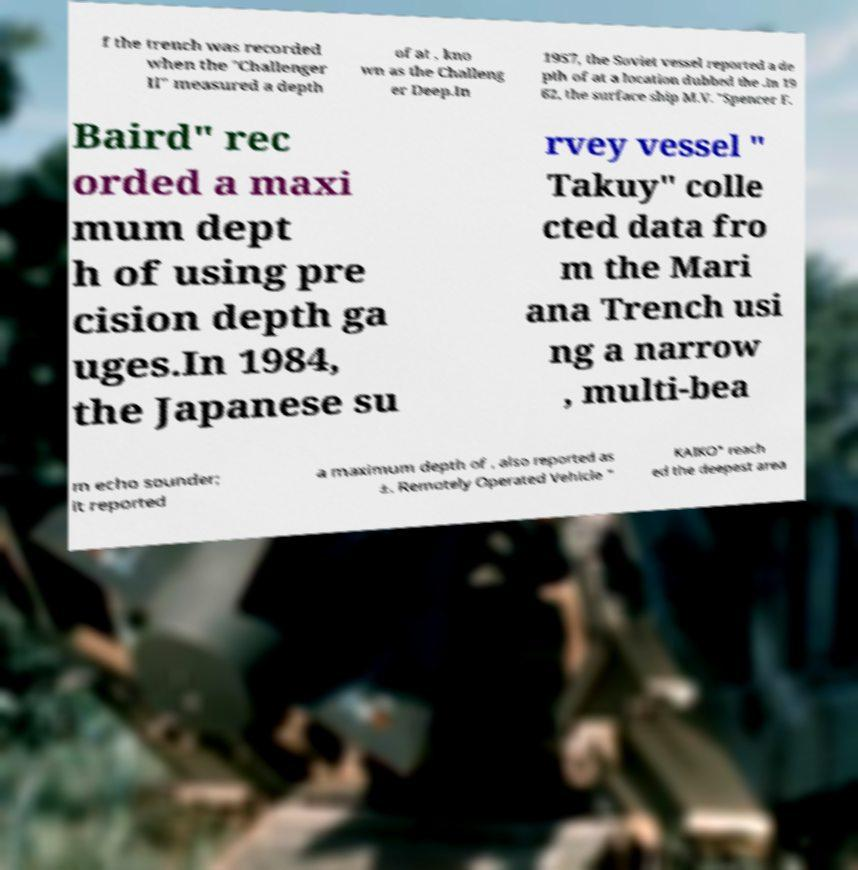Can you read and provide the text displayed in the image?This photo seems to have some interesting text. Can you extract and type it out for me? f the trench was recorded when the "Challenger II" measured a depth of at , kno wn as the Challeng er Deep.In 1957, the Soviet vessel reported a de pth of at a location dubbed the .In 19 62, the surface ship M.V. "Spencer F. Baird" rec orded a maxi mum dept h of using pre cision depth ga uges.In 1984, the Japanese su rvey vessel " Takuy" colle cted data fro m the Mari ana Trench usi ng a narrow , multi-bea m echo sounder; it reported a maximum depth of , also reported as ±. Remotely Operated Vehicle " KAIKO" reach ed the deepest area 